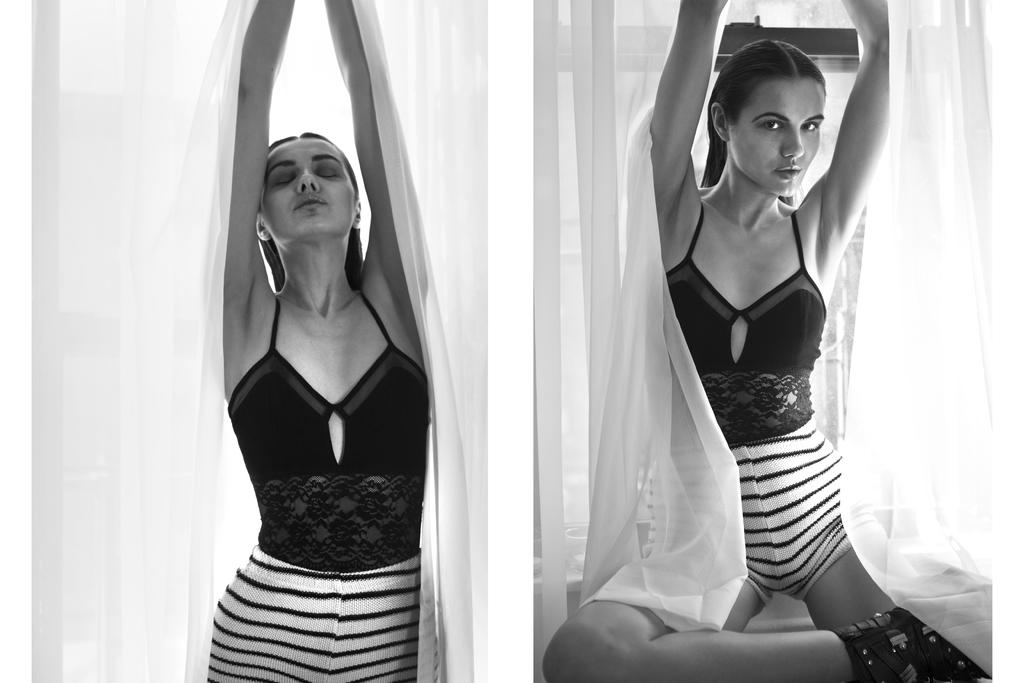What type of image is being described? The image is a collage. What can be observed about the subjects in the image? There are similar women in different postures in the image. What type of background can be seen in the image? There are curtains visible in the image. What color scheme is used in the image? The image is in black and white. What type of seed is being planted in the image? There is no seed or planting activity depicted in the image; it is a collage of similar women in different postures with a black and white color scheme and curtains in the background. 